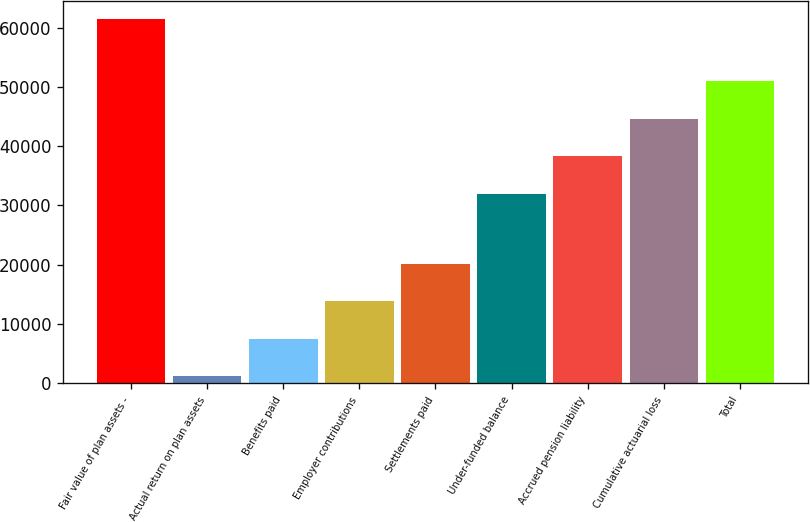Convert chart. <chart><loc_0><loc_0><loc_500><loc_500><bar_chart><fcel>Fair value of plan assets -<fcel>Actual return on plan assets<fcel>Benefits paid<fcel>Employer contributions<fcel>Settlements paid<fcel>Under-funded balance<fcel>Accrued pension liability<fcel>Cumulative actuarial loss<fcel>Total<nl><fcel>61398<fcel>1235<fcel>7560.5<fcel>13886<fcel>20211.5<fcel>31980<fcel>38305.5<fcel>44631<fcel>50956.5<nl></chart> 